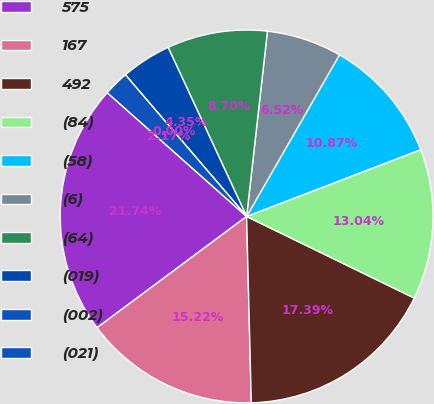Convert chart to OTSL. <chart><loc_0><loc_0><loc_500><loc_500><pie_chart><fcel>575<fcel>167<fcel>492<fcel>(84)<fcel>(58)<fcel>(6)<fcel>(64)<fcel>(019)<fcel>(002)<fcel>(021)<nl><fcel>21.74%<fcel>15.22%<fcel>17.39%<fcel>13.04%<fcel>10.87%<fcel>6.52%<fcel>8.7%<fcel>4.35%<fcel>0.0%<fcel>2.17%<nl></chart> 